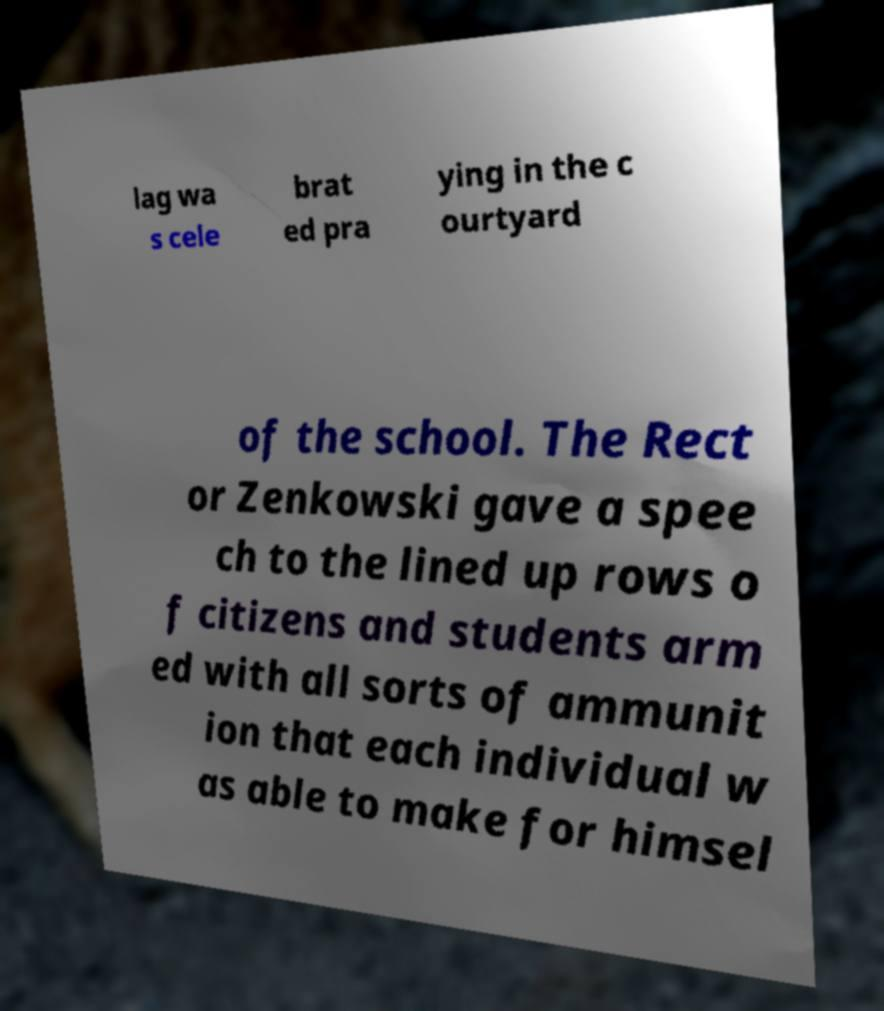I need the written content from this picture converted into text. Can you do that? lag wa s cele brat ed pra ying in the c ourtyard of the school. The Rect or Zenkowski gave a spee ch to the lined up rows o f citizens and students arm ed with all sorts of ammunit ion that each individual w as able to make for himsel 